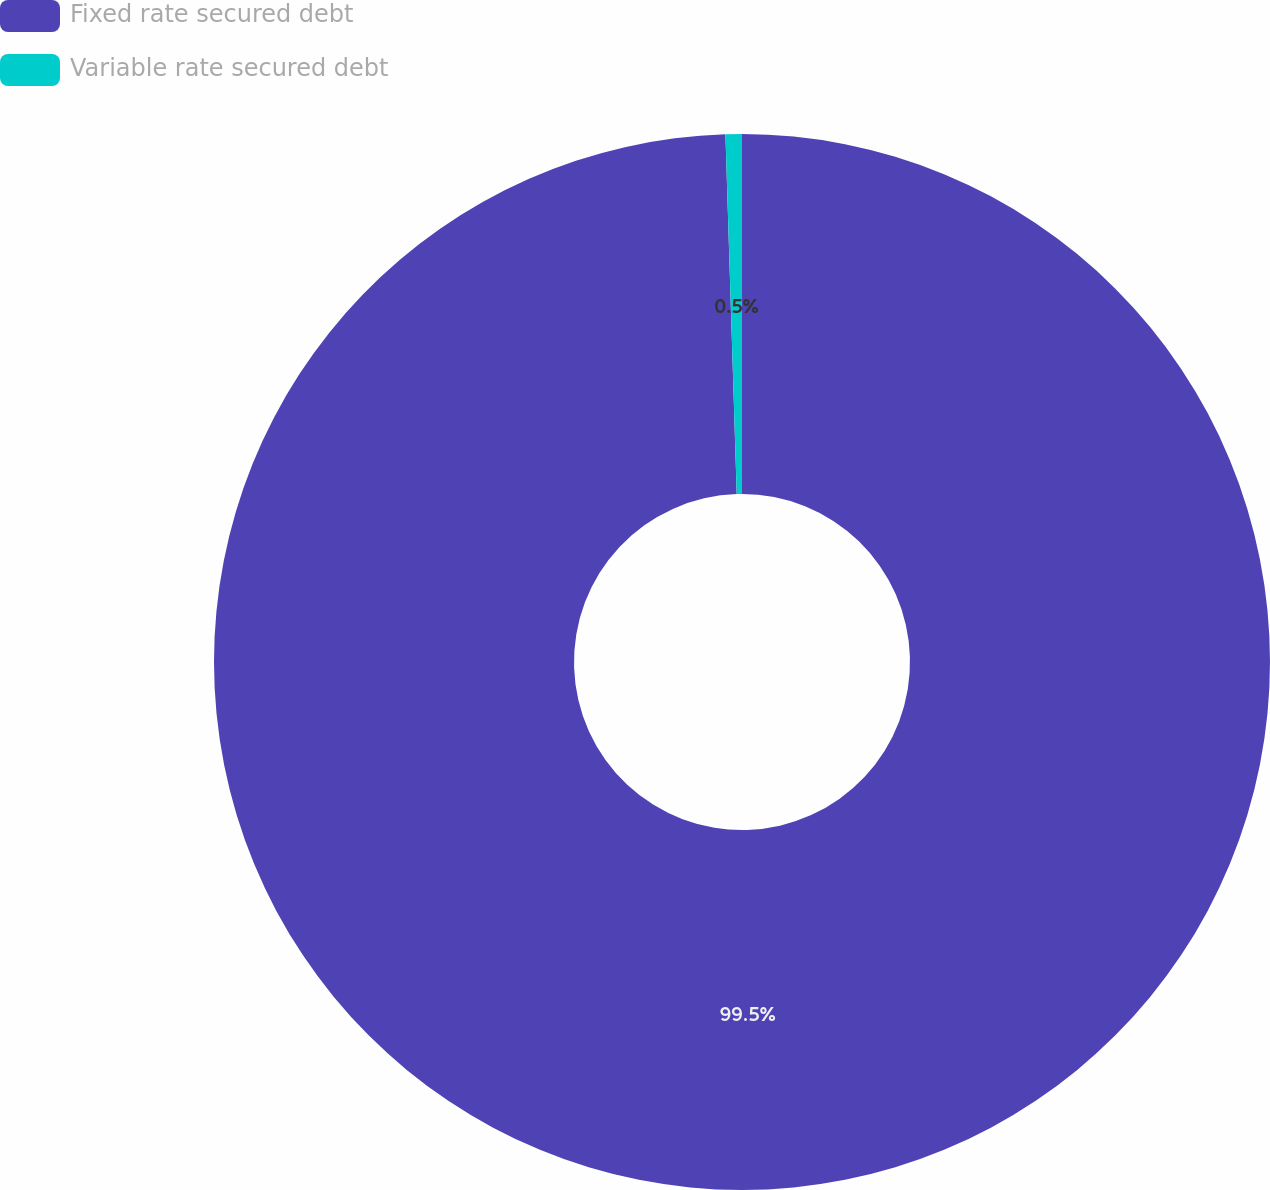Convert chart to OTSL. <chart><loc_0><loc_0><loc_500><loc_500><pie_chart><fcel>Fixed rate secured debt<fcel>Variable rate secured debt<nl><fcel>99.5%<fcel>0.5%<nl></chart> 